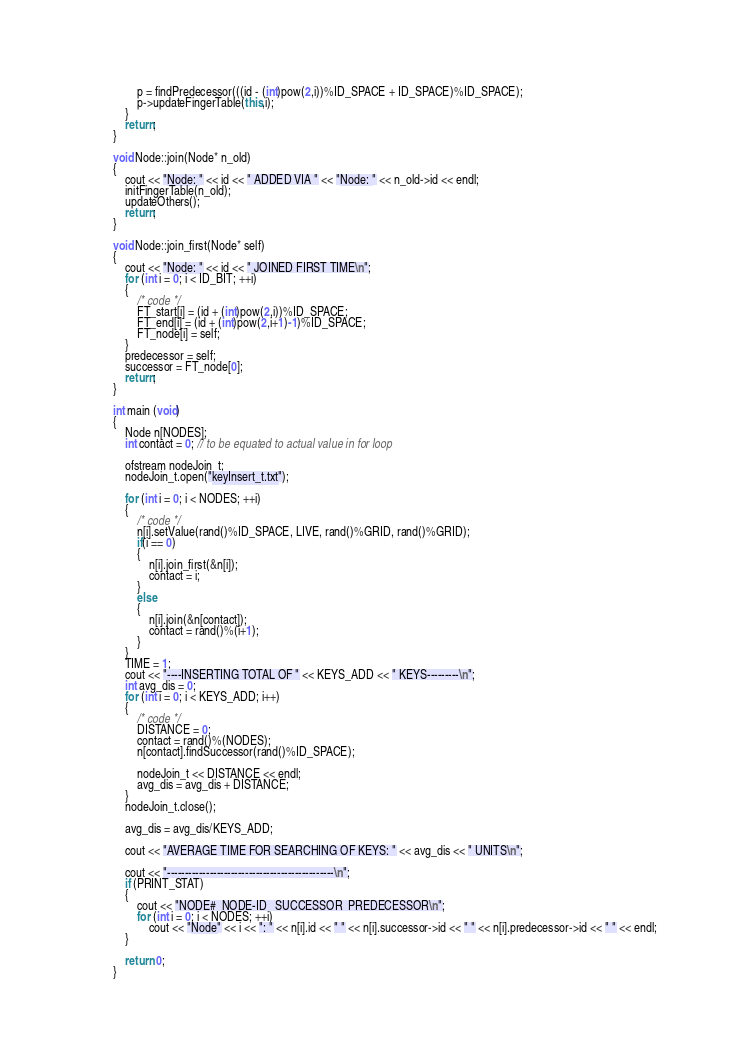<code> <loc_0><loc_0><loc_500><loc_500><_C++_>        p = findPredecessor(((id - (int)pow(2,i))%ID_SPACE + ID_SPACE)%ID_SPACE);
        p->updateFingerTable(this,i);
    }
    return;
}

void Node::join(Node* n_old)
{
    cout << "Node: " << id << " ADDED VIA " << "Node: " << n_old->id << endl;
    initFingerTable(n_old);
    updateOthers();
    return;
}

void Node::join_first(Node* self)
{
    cout << "Node: " << id << " JOINED FIRST TIME\n";
    for (int i = 0; i < ID_BIT; ++i)
    {
        /* code */
        FT_start[i] = (id + (int)pow(2,i))%ID_SPACE;
        FT_end[i] = (id + (int)pow(2,i+1)-1)%ID_SPACE;
        FT_node[i] = self;
    }
    predecessor = self;
    successor = FT_node[0];
    return;
}

int main (void)
{
    Node n[NODES];
    int contact = 0; // to be equated to actual value in for loop

    ofstream nodeJoin_t;
    nodeJoin_t.open("keyInsert_t.txt");

    for (int i = 0; i < NODES; ++i)
    {
        /* code */
        n[i].setValue(rand()%ID_SPACE, LIVE, rand()%GRID, rand()%GRID);
        if(i == 0)
        {
            n[i].join_first(&n[i]);
            contact = i;
        }
        else
        {
            n[i].join(&n[contact]);
            contact = rand()%(i+1);
        }
    }
    TIME = 1;
    cout << "----INSERTING TOTAL OF " << KEYS_ADD << " KEYS---------\n";
    int avg_dis = 0;
    for (int i = 0; i < KEYS_ADD; i++)
    {
        /* code */
        DISTANCE = 0;
        contact = rand()%(NODES);
        n[contact].findSuccessor(rand()%ID_SPACE);
        
        nodeJoin_t << DISTANCE << endl;
        avg_dis = avg_dis + DISTANCE;
    }
    nodeJoin_t.close();

    avg_dis = avg_dis/KEYS_ADD;

    cout << "AVERAGE TIME FOR SEARCHING OF KEYS: " << avg_dis << " UNITS\n";

    cout << "-----------------------------------------------\n";
    if (PRINT_STAT)
    {
        cout << "NODE#  NODE-ID   SUCCESSOR  PREDECESSOR\n";
        for (int i = 0; i < NODES; ++i)
            cout << "Node" << i << ": " << n[i].id << " " << n[i].successor->id << " " << n[i].predecessor->id << " " << endl;
    }

    return 0;
}
</code> 